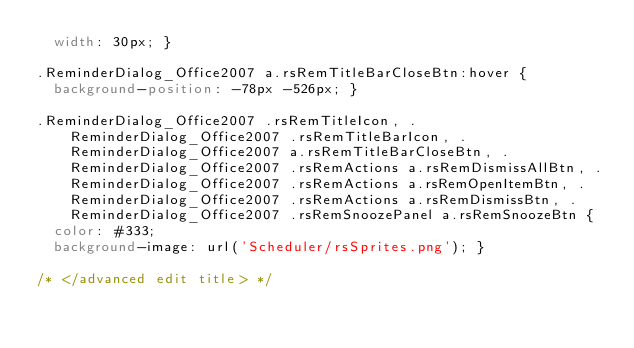<code> <loc_0><loc_0><loc_500><loc_500><_CSS_>  width: 30px; }

.ReminderDialog_Office2007 a.rsRemTitleBarCloseBtn:hover {
  background-position: -78px -526px; }

.ReminderDialog_Office2007 .rsRemTitleIcon, .ReminderDialog_Office2007 .rsRemTitleBarIcon, .ReminderDialog_Office2007 a.rsRemTitleBarCloseBtn, .ReminderDialog_Office2007 .rsRemActions a.rsRemDismissAllBtn, .ReminderDialog_Office2007 .rsRemActions a.rsRemOpenItemBtn, .ReminderDialog_Office2007 .rsRemActions a.rsRemDismissBtn, .ReminderDialog_Office2007 .rsRemSnoozePanel a.rsRemSnoozeBtn {
  color: #333;
  background-image: url('Scheduler/rsSprites.png'); }

/* </advanced edit title> */</code> 